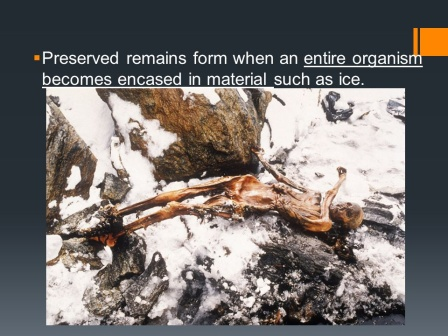How does this image contribute to our understanding of fossilization processes? This image is a prime example of how organisms can become naturally preserved through a process known as freezing. When an organism is encased in ice shortly after death, the low temperatures can halt decomposition, effectively 'suspending' it in time. Unlike typical fossilization, which can take millions of years and result in mineralized remnants, freezing can preserve an organism's tissues for thousands of years, providing valuable, uncontaminated genetic material and insights into its physiology, diet, and living conditions. Such specimens are invaluable for scientists tracking climatic shifts and studying extinct species. How might the surrounding environment change the preservation state of this skeleton? The preservation state of this skeleton could be significantly influenced by changes in the surrounding environment. If the local climate warms, causing ice and snow to melt, the organism might undergo rapid decomposition, losing much of its preserved state. Conversely, if the area remains cold or becomes even colder, the preservation could be maintained or enhanced, potentially freezing more of the surrounding material and encasing the skeleton further. Additionally, shifts like increased moisture or the presence of microbial life could either accelerate decay or cause mineralization and partial fossilization. What if this image depicts not Earth but an alien planet's surface, imagine and describe the scenario. Imagine this image displays a distant, icy world orbiting a dying star in the far reaches of the galaxy. The planet, named Cryo-Terra, is characterized by its unforgiving climate and treacherous landscapes wrapped in perpetual winter. The skeletal remains belong to Xylox, an explorer from an advanced, humanoid alien species known for their quest-driven society. Xylox's expedition aimed to uncover ancient relics and knowledge preserved in the planet's ice. However, a sudden, violent storm trapped him in an isolated valley, his communication devices rendered useless by the extreme conditions. As the temperature plummeted, he succumbed to the cold, his body quickly encased in ice. Thousands of years later, scientists from another world discover his well-preserved remains, puzzled and fascinated by the clues left behind about Xylox's mission and the secrets of Cryo-Terra. The exploration of Xylox's remains could unveil advanced ancient technologies and forgotten knowledge, heralding a new era of understanding and technological advancement for the galaxy. 